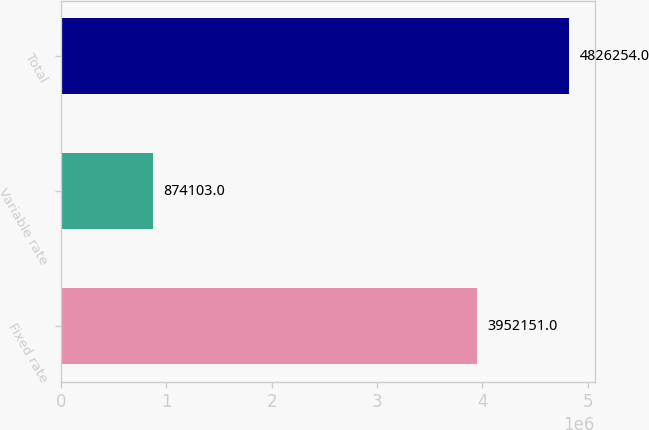Convert chart to OTSL. <chart><loc_0><loc_0><loc_500><loc_500><bar_chart><fcel>Fixed rate<fcel>Variable rate<fcel>Total<nl><fcel>3.95215e+06<fcel>874103<fcel>4.82625e+06<nl></chart> 